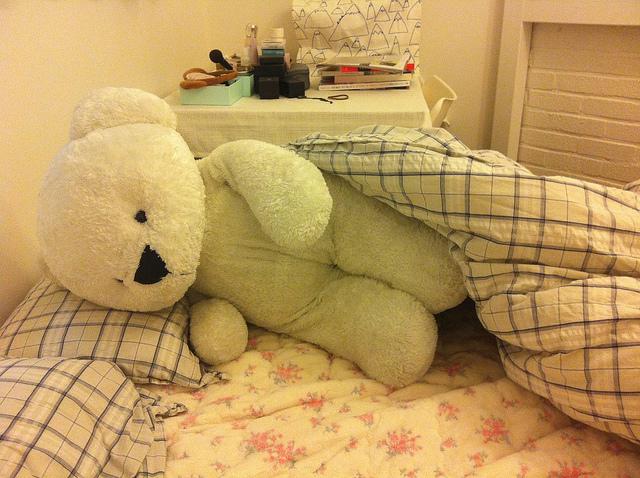Is this a girl or boy's room?
Be succinct. Girl. What is on top of the white animal?
Answer briefly. Blanket. What color is the bear?
Short answer required. White. Is anyone cuddling with the bear in bed?
Give a very brief answer. No. How many stuffed animals are there?
Concise answer only. 1. 